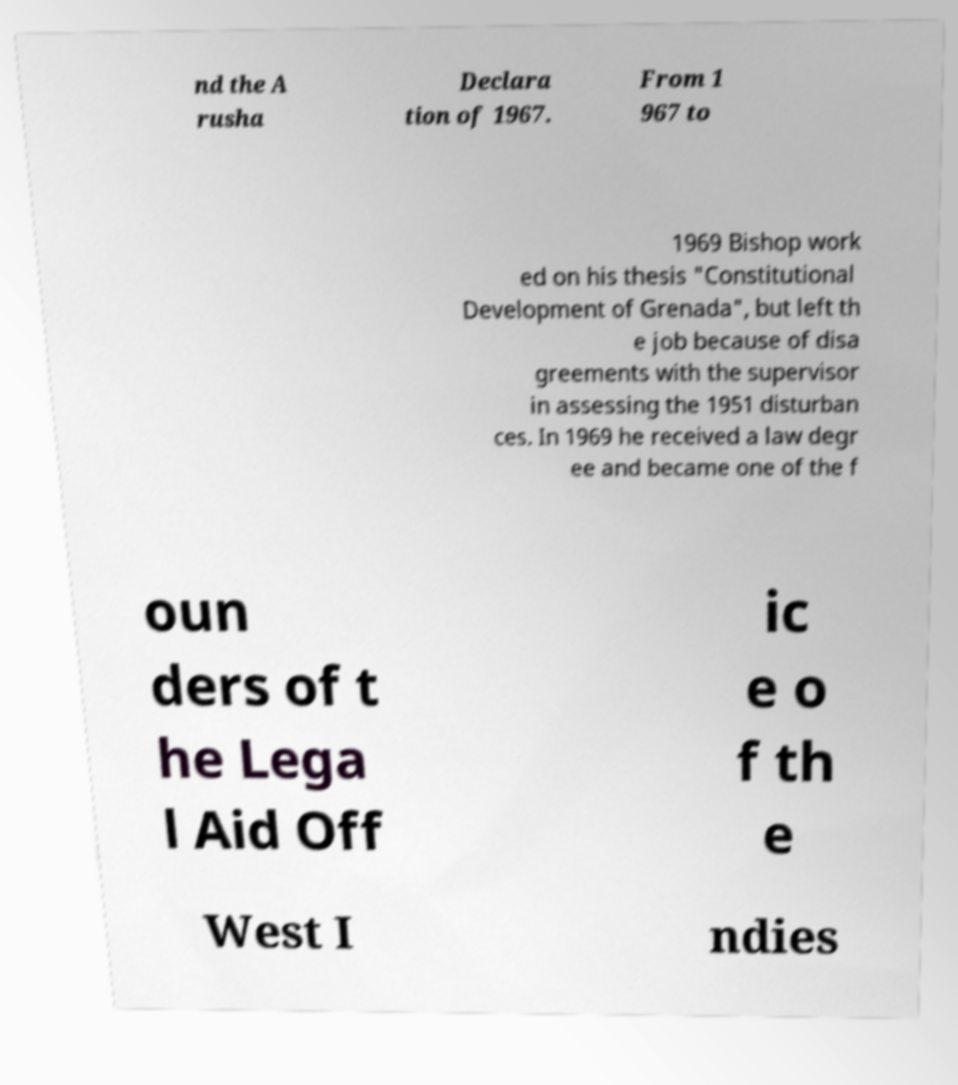Please identify and transcribe the text found in this image. nd the A rusha Declara tion of 1967. From 1 967 to 1969 Bishop work ed on his thesis "Constitutional Development of Grenada", but left th e job because of disa greements with the supervisor in assessing the 1951 disturban ces. In 1969 he received a law degr ee and became one of the f oun ders of t he Lega l Aid Off ic e o f th e West I ndies 